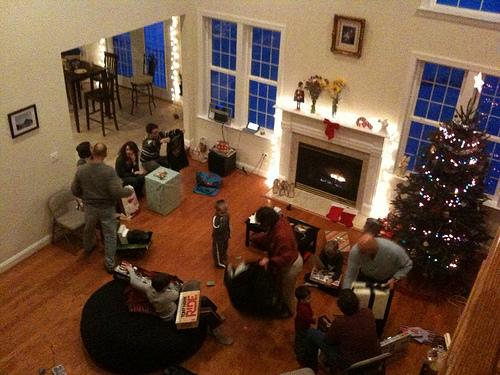What can often be found under the tree seen here? presents 